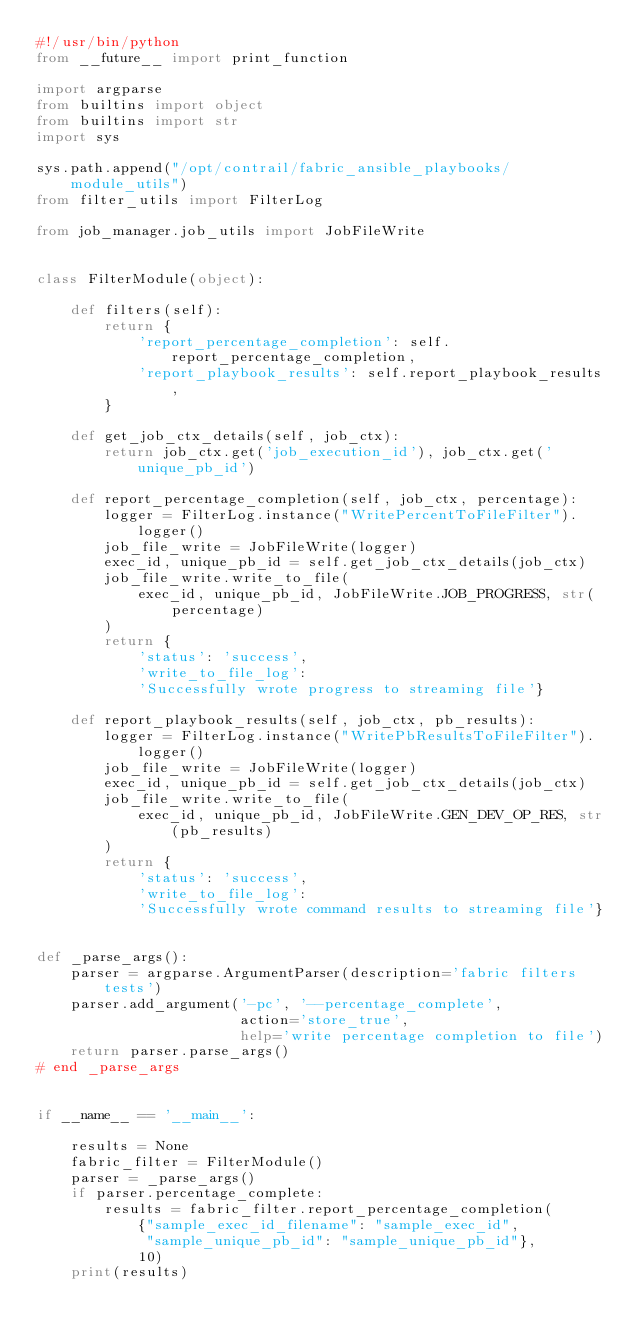Convert code to text. <code><loc_0><loc_0><loc_500><loc_500><_Python_>#!/usr/bin/python
from __future__ import print_function

import argparse
from builtins import object
from builtins import str
import sys

sys.path.append("/opt/contrail/fabric_ansible_playbooks/module_utils")
from filter_utils import FilterLog

from job_manager.job_utils import JobFileWrite


class FilterModule(object):

    def filters(self):
        return {
            'report_percentage_completion': self.report_percentage_completion,
            'report_playbook_results': self.report_playbook_results,
        }

    def get_job_ctx_details(self, job_ctx):
        return job_ctx.get('job_execution_id'), job_ctx.get('unique_pb_id')

    def report_percentage_completion(self, job_ctx, percentage):
        logger = FilterLog.instance("WritePercentToFileFilter").logger()
        job_file_write = JobFileWrite(logger)
        exec_id, unique_pb_id = self.get_job_ctx_details(job_ctx)
        job_file_write.write_to_file(
            exec_id, unique_pb_id, JobFileWrite.JOB_PROGRESS, str(percentage)
        )
        return {
            'status': 'success',
            'write_to_file_log':
            'Successfully wrote progress to streaming file'}

    def report_playbook_results(self, job_ctx, pb_results):
        logger = FilterLog.instance("WritePbResultsToFileFilter").logger()
        job_file_write = JobFileWrite(logger)
        exec_id, unique_pb_id = self.get_job_ctx_details(job_ctx)
        job_file_write.write_to_file(
            exec_id, unique_pb_id, JobFileWrite.GEN_DEV_OP_RES, str(pb_results)
        )
        return {
            'status': 'success',
            'write_to_file_log':
            'Successfully wrote command results to streaming file'}


def _parse_args():
    parser = argparse.ArgumentParser(description='fabric filters tests')
    parser.add_argument('-pc', '--percentage_complete',
                        action='store_true',
                        help='write percentage completion to file')
    return parser.parse_args()
# end _parse_args


if __name__ == '__main__':

    results = None
    fabric_filter = FilterModule()
    parser = _parse_args()
    if parser.percentage_complete:
        results = fabric_filter.report_percentage_completion(
            {"sample_exec_id_filename": "sample_exec_id",
             "sample_unique_pb_id": "sample_unique_pb_id"},
            10)
    print(results)
</code> 